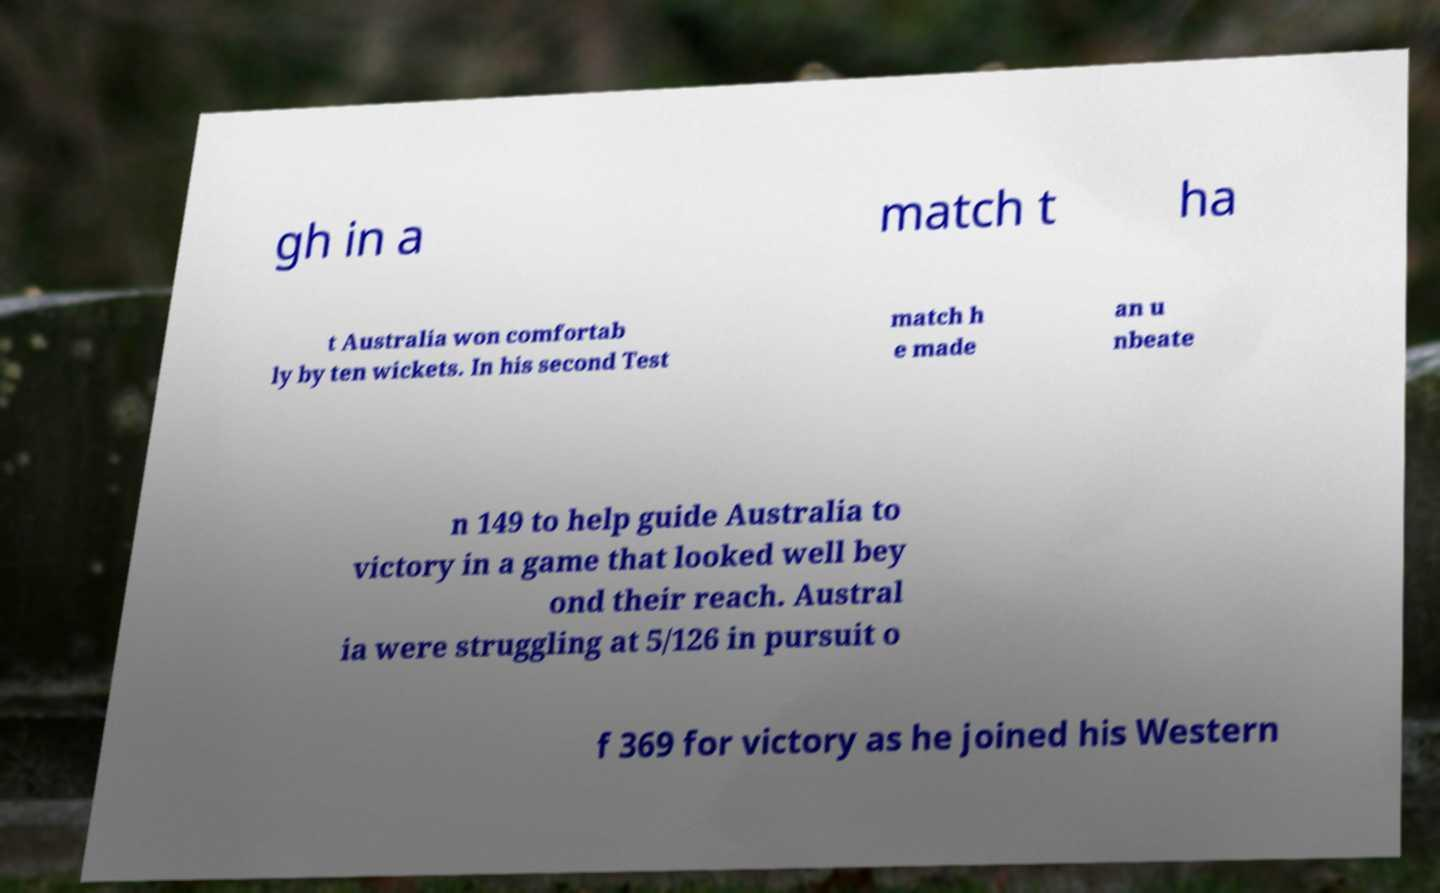Please identify and transcribe the text found in this image. gh in a match t ha t Australia won comfortab ly by ten wickets. In his second Test match h e made an u nbeate n 149 to help guide Australia to victory in a game that looked well bey ond their reach. Austral ia were struggling at 5/126 in pursuit o f 369 for victory as he joined his Western 